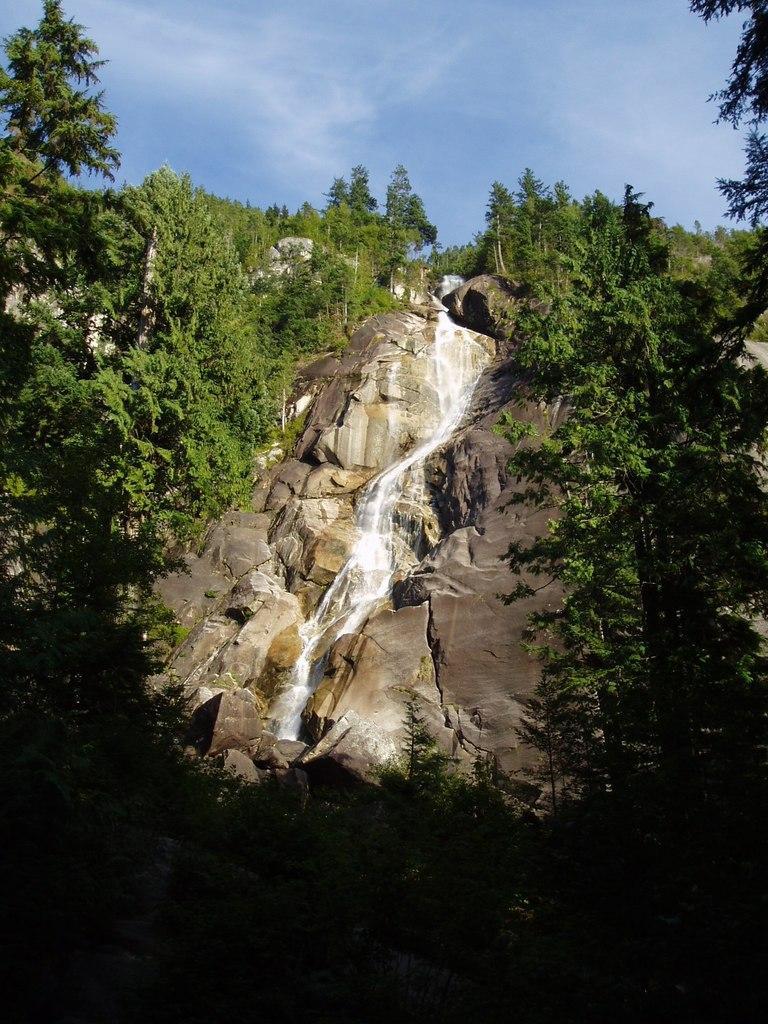Describe this image in one or two sentences. In this picture i can see the waterfall. On the both sides i can see the trees, plants and stones. At the top i can see the sky and clouds. 